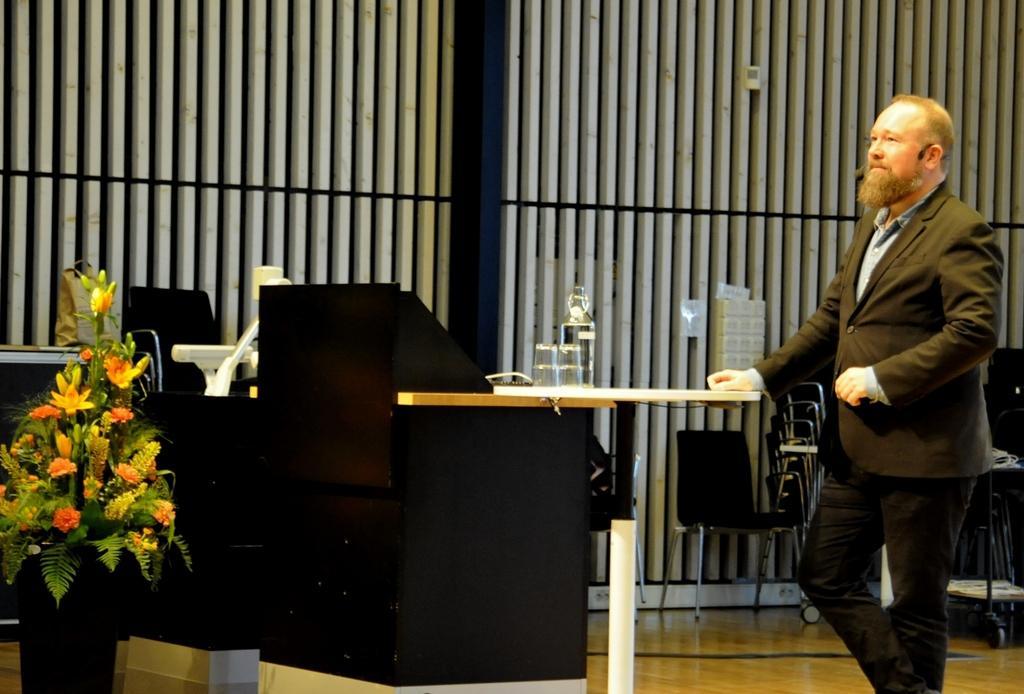Please provide a concise description of this image. In this image I can see the person standing and the person is wearing black color blazer and I can also see few glass objects on the table. In front I can see the flower vase, few chairs and I can see the white and black color background. 